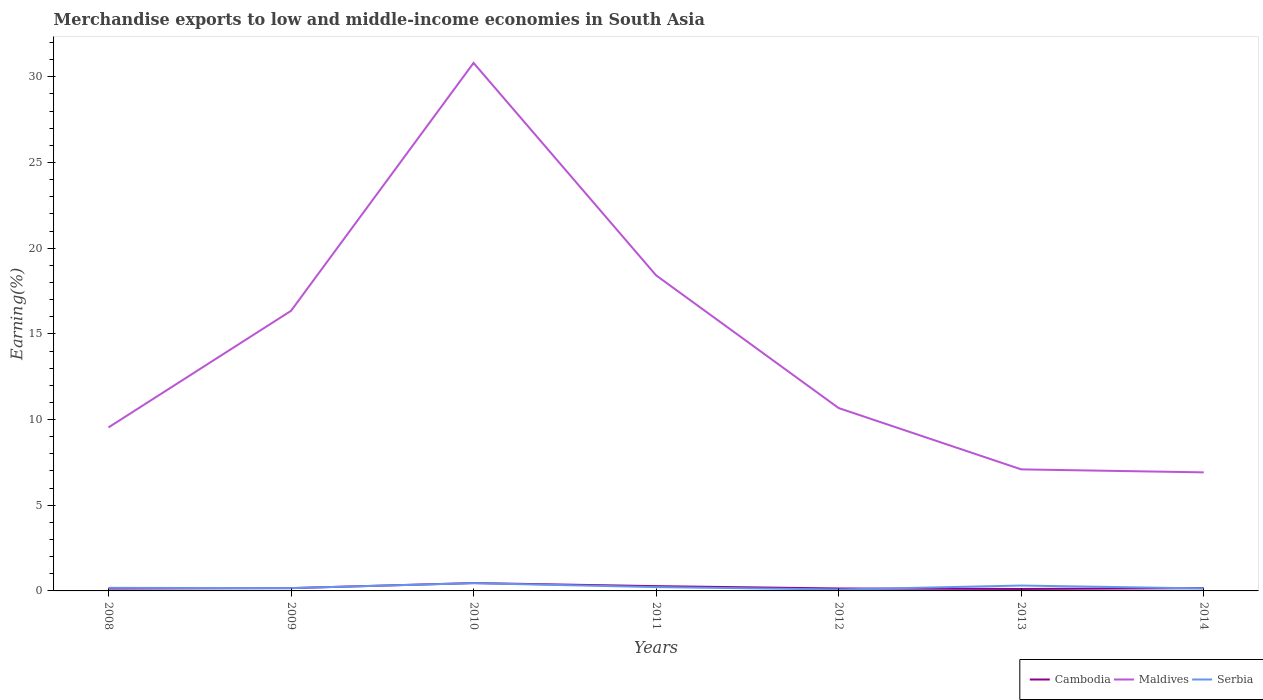Is the number of lines equal to the number of legend labels?
Make the answer very short. Yes. Across all years, what is the maximum percentage of amount earned from merchandise exports in Serbia?
Make the answer very short. 0.08. In which year was the percentage of amount earned from merchandise exports in Maldives maximum?
Provide a short and direct response. 2014. What is the total percentage of amount earned from merchandise exports in Maldives in the graph?
Offer a very short reply. 5.67. What is the difference between the highest and the second highest percentage of amount earned from merchandise exports in Cambodia?
Provide a short and direct response. 0.34. How many lines are there?
Your answer should be compact. 3. How many years are there in the graph?
Your answer should be compact. 7. Does the graph contain any zero values?
Provide a short and direct response. No. Where does the legend appear in the graph?
Ensure brevity in your answer.  Bottom right. What is the title of the graph?
Make the answer very short. Merchandise exports to low and middle-income economies in South Asia. What is the label or title of the X-axis?
Your answer should be compact. Years. What is the label or title of the Y-axis?
Your answer should be compact. Earning(%). What is the Earning(%) in Cambodia in 2008?
Offer a very short reply. 0.14. What is the Earning(%) of Maldives in 2008?
Keep it short and to the point. 9.54. What is the Earning(%) of Serbia in 2008?
Offer a terse response. 0.18. What is the Earning(%) in Cambodia in 2009?
Keep it short and to the point. 0.16. What is the Earning(%) in Maldives in 2009?
Offer a terse response. 16.35. What is the Earning(%) in Serbia in 2009?
Keep it short and to the point. 0.16. What is the Earning(%) of Cambodia in 2010?
Your answer should be very brief. 0.46. What is the Earning(%) in Maldives in 2010?
Provide a succinct answer. 30.81. What is the Earning(%) in Serbia in 2010?
Your answer should be compact. 0.45. What is the Earning(%) in Cambodia in 2011?
Make the answer very short. 0.28. What is the Earning(%) of Maldives in 2011?
Keep it short and to the point. 18.41. What is the Earning(%) in Serbia in 2011?
Provide a short and direct response. 0.22. What is the Earning(%) in Cambodia in 2012?
Provide a short and direct response. 0.14. What is the Earning(%) of Maldives in 2012?
Keep it short and to the point. 10.67. What is the Earning(%) in Serbia in 2012?
Your answer should be compact. 0.08. What is the Earning(%) in Cambodia in 2013?
Your answer should be compact. 0.11. What is the Earning(%) in Maldives in 2013?
Provide a short and direct response. 7.09. What is the Earning(%) in Serbia in 2013?
Provide a succinct answer. 0.31. What is the Earning(%) in Cambodia in 2014?
Your answer should be very brief. 0.16. What is the Earning(%) in Maldives in 2014?
Your response must be concise. 6.92. What is the Earning(%) in Serbia in 2014?
Your response must be concise. 0.14. Across all years, what is the maximum Earning(%) of Cambodia?
Provide a succinct answer. 0.46. Across all years, what is the maximum Earning(%) in Maldives?
Offer a very short reply. 30.81. Across all years, what is the maximum Earning(%) of Serbia?
Offer a terse response. 0.45. Across all years, what is the minimum Earning(%) in Cambodia?
Keep it short and to the point. 0.11. Across all years, what is the minimum Earning(%) in Maldives?
Your answer should be very brief. 6.92. Across all years, what is the minimum Earning(%) of Serbia?
Give a very brief answer. 0.08. What is the total Earning(%) of Cambodia in the graph?
Give a very brief answer. 1.45. What is the total Earning(%) of Maldives in the graph?
Your response must be concise. 99.79. What is the total Earning(%) of Serbia in the graph?
Your response must be concise. 1.56. What is the difference between the Earning(%) of Cambodia in 2008 and that in 2009?
Offer a terse response. -0.03. What is the difference between the Earning(%) in Maldives in 2008 and that in 2009?
Ensure brevity in your answer.  -6.81. What is the difference between the Earning(%) in Serbia in 2008 and that in 2009?
Make the answer very short. 0.02. What is the difference between the Earning(%) in Cambodia in 2008 and that in 2010?
Your answer should be compact. -0.32. What is the difference between the Earning(%) of Maldives in 2008 and that in 2010?
Your response must be concise. -21.27. What is the difference between the Earning(%) of Serbia in 2008 and that in 2010?
Provide a succinct answer. -0.27. What is the difference between the Earning(%) in Cambodia in 2008 and that in 2011?
Provide a succinct answer. -0.14. What is the difference between the Earning(%) in Maldives in 2008 and that in 2011?
Your answer should be very brief. -8.87. What is the difference between the Earning(%) of Serbia in 2008 and that in 2011?
Your response must be concise. -0.04. What is the difference between the Earning(%) in Cambodia in 2008 and that in 2012?
Provide a short and direct response. -0.01. What is the difference between the Earning(%) in Maldives in 2008 and that in 2012?
Provide a short and direct response. -1.13. What is the difference between the Earning(%) in Serbia in 2008 and that in 2012?
Give a very brief answer. 0.1. What is the difference between the Earning(%) in Cambodia in 2008 and that in 2013?
Provide a succinct answer. 0.02. What is the difference between the Earning(%) of Maldives in 2008 and that in 2013?
Your response must be concise. 2.45. What is the difference between the Earning(%) of Serbia in 2008 and that in 2013?
Give a very brief answer. -0.13. What is the difference between the Earning(%) of Cambodia in 2008 and that in 2014?
Provide a short and direct response. -0.03. What is the difference between the Earning(%) of Maldives in 2008 and that in 2014?
Provide a succinct answer. 2.62. What is the difference between the Earning(%) in Serbia in 2008 and that in 2014?
Give a very brief answer. 0.04. What is the difference between the Earning(%) of Cambodia in 2009 and that in 2010?
Your answer should be compact. -0.3. What is the difference between the Earning(%) in Maldives in 2009 and that in 2010?
Keep it short and to the point. -14.47. What is the difference between the Earning(%) of Serbia in 2009 and that in 2010?
Provide a succinct answer. -0.29. What is the difference between the Earning(%) of Cambodia in 2009 and that in 2011?
Ensure brevity in your answer.  -0.11. What is the difference between the Earning(%) in Maldives in 2009 and that in 2011?
Keep it short and to the point. -2.07. What is the difference between the Earning(%) in Serbia in 2009 and that in 2011?
Ensure brevity in your answer.  -0.06. What is the difference between the Earning(%) of Cambodia in 2009 and that in 2012?
Keep it short and to the point. 0.02. What is the difference between the Earning(%) in Maldives in 2009 and that in 2012?
Offer a very short reply. 5.67. What is the difference between the Earning(%) in Serbia in 2009 and that in 2012?
Provide a short and direct response. 0.08. What is the difference between the Earning(%) of Cambodia in 2009 and that in 2013?
Provide a short and direct response. 0.05. What is the difference between the Earning(%) of Maldives in 2009 and that in 2013?
Your answer should be compact. 9.25. What is the difference between the Earning(%) of Serbia in 2009 and that in 2013?
Your answer should be compact. -0.15. What is the difference between the Earning(%) of Cambodia in 2009 and that in 2014?
Ensure brevity in your answer.  0. What is the difference between the Earning(%) in Maldives in 2009 and that in 2014?
Offer a terse response. 9.43. What is the difference between the Earning(%) of Serbia in 2009 and that in 2014?
Offer a terse response. 0.02. What is the difference between the Earning(%) of Cambodia in 2010 and that in 2011?
Provide a succinct answer. 0.18. What is the difference between the Earning(%) in Maldives in 2010 and that in 2011?
Offer a very short reply. 12.4. What is the difference between the Earning(%) of Serbia in 2010 and that in 2011?
Make the answer very short. 0.23. What is the difference between the Earning(%) in Cambodia in 2010 and that in 2012?
Offer a terse response. 0.32. What is the difference between the Earning(%) of Maldives in 2010 and that in 2012?
Provide a succinct answer. 20.14. What is the difference between the Earning(%) in Serbia in 2010 and that in 2012?
Your response must be concise. 0.37. What is the difference between the Earning(%) of Cambodia in 2010 and that in 2013?
Keep it short and to the point. 0.34. What is the difference between the Earning(%) in Maldives in 2010 and that in 2013?
Provide a short and direct response. 23.72. What is the difference between the Earning(%) of Serbia in 2010 and that in 2013?
Give a very brief answer. 0.14. What is the difference between the Earning(%) of Cambodia in 2010 and that in 2014?
Give a very brief answer. 0.3. What is the difference between the Earning(%) in Maldives in 2010 and that in 2014?
Make the answer very short. 23.89. What is the difference between the Earning(%) in Serbia in 2010 and that in 2014?
Your answer should be very brief. 0.31. What is the difference between the Earning(%) of Cambodia in 2011 and that in 2012?
Offer a very short reply. 0.14. What is the difference between the Earning(%) of Maldives in 2011 and that in 2012?
Provide a short and direct response. 7.74. What is the difference between the Earning(%) of Serbia in 2011 and that in 2012?
Give a very brief answer. 0.14. What is the difference between the Earning(%) of Cambodia in 2011 and that in 2013?
Offer a terse response. 0.16. What is the difference between the Earning(%) of Maldives in 2011 and that in 2013?
Ensure brevity in your answer.  11.32. What is the difference between the Earning(%) of Serbia in 2011 and that in 2013?
Keep it short and to the point. -0.09. What is the difference between the Earning(%) of Cambodia in 2011 and that in 2014?
Ensure brevity in your answer.  0.12. What is the difference between the Earning(%) of Maldives in 2011 and that in 2014?
Offer a very short reply. 11.5. What is the difference between the Earning(%) in Serbia in 2011 and that in 2014?
Your answer should be very brief. 0.08. What is the difference between the Earning(%) of Cambodia in 2012 and that in 2013?
Provide a succinct answer. 0.03. What is the difference between the Earning(%) in Maldives in 2012 and that in 2013?
Offer a terse response. 3.58. What is the difference between the Earning(%) of Serbia in 2012 and that in 2013?
Your answer should be very brief. -0.23. What is the difference between the Earning(%) of Cambodia in 2012 and that in 2014?
Your answer should be very brief. -0.02. What is the difference between the Earning(%) in Maldives in 2012 and that in 2014?
Keep it short and to the point. 3.75. What is the difference between the Earning(%) of Serbia in 2012 and that in 2014?
Your answer should be compact. -0.06. What is the difference between the Earning(%) in Cambodia in 2013 and that in 2014?
Keep it short and to the point. -0.05. What is the difference between the Earning(%) of Maldives in 2013 and that in 2014?
Provide a succinct answer. 0.17. What is the difference between the Earning(%) in Serbia in 2013 and that in 2014?
Your answer should be compact. 0.17. What is the difference between the Earning(%) of Cambodia in 2008 and the Earning(%) of Maldives in 2009?
Provide a short and direct response. -16.21. What is the difference between the Earning(%) in Cambodia in 2008 and the Earning(%) in Serbia in 2009?
Keep it short and to the point. -0.03. What is the difference between the Earning(%) in Maldives in 2008 and the Earning(%) in Serbia in 2009?
Offer a terse response. 9.38. What is the difference between the Earning(%) of Cambodia in 2008 and the Earning(%) of Maldives in 2010?
Your response must be concise. -30.68. What is the difference between the Earning(%) in Cambodia in 2008 and the Earning(%) in Serbia in 2010?
Provide a short and direct response. -0.32. What is the difference between the Earning(%) in Maldives in 2008 and the Earning(%) in Serbia in 2010?
Offer a very short reply. 9.09. What is the difference between the Earning(%) of Cambodia in 2008 and the Earning(%) of Maldives in 2011?
Your answer should be compact. -18.28. What is the difference between the Earning(%) in Cambodia in 2008 and the Earning(%) in Serbia in 2011?
Offer a terse response. -0.09. What is the difference between the Earning(%) in Maldives in 2008 and the Earning(%) in Serbia in 2011?
Offer a very short reply. 9.32. What is the difference between the Earning(%) of Cambodia in 2008 and the Earning(%) of Maldives in 2012?
Provide a short and direct response. -10.54. What is the difference between the Earning(%) in Cambodia in 2008 and the Earning(%) in Serbia in 2012?
Make the answer very short. 0.05. What is the difference between the Earning(%) of Maldives in 2008 and the Earning(%) of Serbia in 2012?
Keep it short and to the point. 9.46. What is the difference between the Earning(%) of Cambodia in 2008 and the Earning(%) of Maldives in 2013?
Keep it short and to the point. -6.96. What is the difference between the Earning(%) of Cambodia in 2008 and the Earning(%) of Serbia in 2013?
Offer a very short reply. -0.18. What is the difference between the Earning(%) of Maldives in 2008 and the Earning(%) of Serbia in 2013?
Give a very brief answer. 9.23. What is the difference between the Earning(%) in Cambodia in 2008 and the Earning(%) in Maldives in 2014?
Offer a terse response. -6.78. What is the difference between the Earning(%) of Cambodia in 2008 and the Earning(%) of Serbia in 2014?
Give a very brief answer. -0.01. What is the difference between the Earning(%) of Maldives in 2008 and the Earning(%) of Serbia in 2014?
Provide a succinct answer. 9.4. What is the difference between the Earning(%) of Cambodia in 2009 and the Earning(%) of Maldives in 2010?
Give a very brief answer. -30.65. What is the difference between the Earning(%) of Cambodia in 2009 and the Earning(%) of Serbia in 2010?
Make the answer very short. -0.29. What is the difference between the Earning(%) in Maldives in 2009 and the Earning(%) in Serbia in 2010?
Ensure brevity in your answer.  15.89. What is the difference between the Earning(%) of Cambodia in 2009 and the Earning(%) of Maldives in 2011?
Provide a succinct answer. -18.25. What is the difference between the Earning(%) of Cambodia in 2009 and the Earning(%) of Serbia in 2011?
Provide a succinct answer. -0.06. What is the difference between the Earning(%) of Maldives in 2009 and the Earning(%) of Serbia in 2011?
Your answer should be compact. 16.12. What is the difference between the Earning(%) in Cambodia in 2009 and the Earning(%) in Maldives in 2012?
Provide a succinct answer. -10.51. What is the difference between the Earning(%) in Cambodia in 2009 and the Earning(%) in Serbia in 2012?
Ensure brevity in your answer.  0.08. What is the difference between the Earning(%) in Maldives in 2009 and the Earning(%) in Serbia in 2012?
Your response must be concise. 16.26. What is the difference between the Earning(%) in Cambodia in 2009 and the Earning(%) in Maldives in 2013?
Keep it short and to the point. -6.93. What is the difference between the Earning(%) of Cambodia in 2009 and the Earning(%) of Serbia in 2013?
Your answer should be compact. -0.15. What is the difference between the Earning(%) in Maldives in 2009 and the Earning(%) in Serbia in 2013?
Ensure brevity in your answer.  16.03. What is the difference between the Earning(%) in Cambodia in 2009 and the Earning(%) in Maldives in 2014?
Make the answer very short. -6.76. What is the difference between the Earning(%) in Cambodia in 2009 and the Earning(%) in Serbia in 2014?
Your response must be concise. 0.02. What is the difference between the Earning(%) of Maldives in 2009 and the Earning(%) of Serbia in 2014?
Your answer should be very brief. 16.2. What is the difference between the Earning(%) of Cambodia in 2010 and the Earning(%) of Maldives in 2011?
Provide a short and direct response. -17.96. What is the difference between the Earning(%) of Cambodia in 2010 and the Earning(%) of Serbia in 2011?
Provide a short and direct response. 0.24. What is the difference between the Earning(%) in Maldives in 2010 and the Earning(%) in Serbia in 2011?
Keep it short and to the point. 30.59. What is the difference between the Earning(%) in Cambodia in 2010 and the Earning(%) in Maldives in 2012?
Make the answer very short. -10.21. What is the difference between the Earning(%) of Cambodia in 2010 and the Earning(%) of Serbia in 2012?
Your response must be concise. 0.38. What is the difference between the Earning(%) of Maldives in 2010 and the Earning(%) of Serbia in 2012?
Make the answer very short. 30.73. What is the difference between the Earning(%) in Cambodia in 2010 and the Earning(%) in Maldives in 2013?
Provide a short and direct response. -6.63. What is the difference between the Earning(%) in Cambodia in 2010 and the Earning(%) in Serbia in 2013?
Ensure brevity in your answer.  0.14. What is the difference between the Earning(%) in Maldives in 2010 and the Earning(%) in Serbia in 2013?
Provide a short and direct response. 30.5. What is the difference between the Earning(%) in Cambodia in 2010 and the Earning(%) in Maldives in 2014?
Your response must be concise. -6.46. What is the difference between the Earning(%) of Cambodia in 2010 and the Earning(%) of Serbia in 2014?
Your answer should be very brief. 0.31. What is the difference between the Earning(%) in Maldives in 2010 and the Earning(%) in Serbia in 2014?
Give a very brief answer. 30.67. What is the difference between the Earning(%) in Cambodia in 2011 and the Earning(%) in Maldives in 2012?
Offer a terse response. -10.39. What is the difference between the Earning(%) in Cambodia in 2011 and the Earning(%) in Serbia in 2012?
Offer a terse response. 0.19. What is the difference between the Earning(%) in Maldives in 2011 and the Earning(%) in Serbia in 2012?
Offer a very short reply. 18.33. What is the difference between the Earning(%) in Cambodia in 2011 and the Earning(%) in Maldives in 2013?
Your answer should be very brief. -6.82. What is the difference between the Earning(%) in Cambodia in 2011 and the Earning(%) in Serbia in 2013?
Provide a succinct answer. -0.04. What is the difference between the Earning(%) of Maldives in 2011 and the Earning(%) of Serbia in 2013?
Provide a short and direct response. 18.1. What is the difference between the Earning(%) in Cambodia in 2011 and the Earning(%) in Maldives in 2014?
Provide a succinct answer. -6.64. What is the difference between the Earning(%) of Cambodia in 2011 and the Earning(%) of Serbia in 2014?
Offer a terse response. 0.13. What is the difference between the Earning(%) of Maldives in 2011 and the Earning(%) of Serbia in 2014?
Make the answer very short. 18.27. What is the difference between the Earning(%) in Cambodia in 2012 and the Earning(%) in Maldives in 2013?
Keep it short and to the point. -6.95. What is the difference between the Earning(%) of Cambodia in 2012 and the Earning(%) of Serbia in 2013?
Your answer should be compact. -0.17. What is the difference between the Earning(%) of Maldives in 2012 and the Earning(%) of Serbia in 2013?
Make the answer very short. 10.36. What is the difference between the Earning(%) of Cambodia in 2012 and the Earning(%) of Maldives in 2014?
Offer a terse response. -6.78. What is the difference between the Earning(%) in Cambodia in 2012 and the Earning(%) in Serbia in 2014?
Offer a terse response. -0. What is the difference between the Earning(%) of Maldives in 2012 and the Earning(%) of Serbia in 2014?
Provide a short and direct response. 10.53. What is the difference between the Earning(%) of Cambodia in 2013 and the Earning(%) of Maldives in 2014?
Make the answer very short. -6.8. What is the difference between the Earning(%) of Cambodia in 2013 and the Earning(%) of Serbia in 2014?
Give a very brief answer. -0.03. What is the difference between the Earning(%) in Maldives in 2013 and the Earning(%) in Serbia in 2014?
Keep it short and to the point. 6.95. What is the average Earning(%) of Cambodia per year?
Ensure brevity in your answer.  0.21. What is the average Earning(%) in Maldives per year?
Your answer should be compact. 14.26. What is the average Earning(%) in Serbia per year?
Your response must be concise. 0.22. In the year 2008, what is the difference between the Earning(%) of Cambodia and Earning(%) of Maldives?
Give a very brief answer. -9.4. In the year 2008, what is the difference between the Earning(%) of Cambodia and Earning(%) of Serbia?
Offer a terse response. -0.04. In the year 2008, what is the difference between the Earning(%) in Maldives and Earning(%) in Serbia?
Give a very brief answer. 9.36. In the year 2009, what is the difference between the Earning(%) of Cambodia and Earning(%) of Maldives?
Keep it short and to the point. -16.18. In the year 2009, what is the difference between the Earning(%) in Cambodia and Earning(%) in Serbia?
Offer a terse response. -0. In the year 2009, what is the difference between the Earning(%) of Maldives and Earning(%) of Serbia?
Keep it short and to the point. 16.18. In the year 2010, what is the difference between the Earning(%) in Cambodia and Earning(%) in Maldives?
Give a very brief answer. -30.35. In the year 2010, what is the difference between the Earning(%) in Cambodia and Earning(%) in Serbia?
Your answer should be very brief. 0.01. In the year 2010, what is the difference between the Earning(%) of Maldives and Earning(%) of Serbia?
Provide a short and direct response. 30.36. In the year 2011, what is the difference between the Earning(%) of Cambodia and Earning(%) of Maldives?
Ensure brevity in your answer.  -18.14. In the year 2011, what is the difference between the Earning(%) of Cambodia and Earning(%) of Serbia?
Offer a terse response. 0.06. In the year 2011, what is the difference between the Earning(%) of Maldives and Earning(%) of Serbia?
Your response must be concise. 18.19. In the year 2012, what is the difference between the Earning(%) of Cambodia and Earning(%) of Maldives?
Keep it short and to the point. -10.53. In the year 2012, what is the difference between the Earning(%) in Cambodia and Earning(%) in Serbia?
Provide a short and direct response. 0.06. In the year 2012, what is the difference between the Earning(%) in Maldives and Earning(%) in Serbia?
Ensure brevity in your answer.  10.59. In the year 2013, what is the difference between the Earning(%) of Cambodia and Earning(%) of Maldives?
Offer a terse response. -6.98. In the year 2013, what is the difference between the Earning(%) in Cambodia and Earning(%) in Serbia?
Your answer should be very brief. -0.2. In the year 2013, what is the difference between the Earning(%) in Maldives and Earning(%) in Serbia?
Give a very brief answer. 6.78. In the year 2014, what is the difference between the Earning(%) in Cambodia and Earning(%) in Maldives?
Provide a short and direct response. -6.76. In the year 2014, what is the difference between the Earning(%) in Cambodia and Earning(%) in Serbia?
Provide a short and direct response. 0.02. In the year 2014, what is the difference between the Earning(%) of Maldives and Earning(%) of Serbia?
Your answer should be very brief. 6.77. What is the ratio of the Earning(%) of Cambodia in 2008 to that in 2009?
Offer a terse response. 0.83. What is the ratio of the Earning(%) of Maldives in 2008 to that in 2009?
Provide a short and direct response. 0.58. What is the ratio of the Earning(%) of Serbia in 2008 to that in 2009?
Give a very brief answer. 1.1. What is the ratio of the Earning(%) of Cambodia in 2008 to that in 2010?
Give a very brief answer. 0.3. What is the ratio of the Earning(%) in Maldives in 2008 to that in 2010?
Give a very brief answer. 0.31. What is the ratio of the Earning(%) of Serbia in 2008 to that in 2010?
Give a very brief answer. 0.4. What is the ratio of the Earning(%) of Cambodia in 2008 to that in 2011?
Make the answer very short. 0.49. What is the ratio of the Earning(%) in Maldives in 2008 to that in 2011?
Offer a very short reply. 0.52. What is the ratio of the Earning(%) of Serbia in 2008 to that in 2011?
Provide a short and direct response. 0.81. What is the ratio of the Earning(%) of Cambodia in 2008 to that in 2012?
Provide a short and direct response. 0.95. What is the ratio of the Earning(%) in Maldives in 2008 to that in 2012?
Your answer should be compact. 0.89. What is the ratio of the Earning(%) in Serbia in 2008 to that in 2012?
Offer a terse response. 2.17. What is the ratio of the Earning(%) of Cambodia in 2008 to that in 2013?
Offer a very short reply. 1.19. What is the ratio of the Earning(%) in Maldives in 2008 to that in 2013?
Your response must be concise. 1.34. What is the ratio of the Earning(%) in Serbia in 2008 to that in 2013?
Your answer should be very brief. 0.57. What is the ratio of the Earning(%) in Cambodia in 2008 to that in 2014?
Offer a terse response. 0.84. What is the ratio of the Earning(%) in Maldives in 2008 to that in 2014?
Provide a succinct answer. 1.38. What is the ratio of the Earning(%) of Serbia in 2008 to that in 2014?
Your answer should be compact. 1.25. What is the ratio of the Earning(%) in Cambodia in 2009 to that in 2010?
Give a very brief answer. 0.36. What is the ratio of the Earning(%) in Maldives in 2009 to that in 2010?
Provide a short and direct response. 0.53. What is the ratio of the Earning(%) of Serbia in 2009 to that in 2010?
Your answer should be compact. 0.36. What is the ratio of the Earning(%) of Cambodia in 2009 to that in 2011?
Make the answer very short. 0.59. What is the ratio of the Earning(%) of Maldives in 2009 to that in 2011?
Give a very brief answer. 0.89. What is the ratio of the Earning(%) of Serbia in 2009 to that in 2011?
Your answer should be compact. 0.74. What is the ratio of the Earning(%) in Cambodia in 2009 to that in 2012?
Your response must be concise. 1.15. What is the ratio of the Earning(%) in Maldives in 2009 to that in 2012?
Your answer should be compact. 1.53. What is the ratio of the Earning(%) in Serbia in 2009 to that in 2012?
Offer a terse response. 1.98. What is the ratio of the Earning(%) in Cambodia in 2009 to that in 2013?
Give a very brief answer. 1.43. What is the ratio of the Earning(%) of Maldives in 2009 to that in 2013?
Provide a succinct answer. 2.3. What is the ratio of the Earning(%) of Serbia in 2009 to that in 2013?
Ensure brevity in your answer.  0.52. What is the ratio of the Earning(%) of Cambodia in 2009 to that in 2014?
Your response must be concise. 1.01. What is the ratio of the Earning(%) of Maldives in 2009 to that in 2014?
Ensure brevity in your answer.  2.36. What is the ratio of the Earning(%) of Serbia in 2009 to that in 2014?
Provide a short and direct response. 1.14. What is the ratio of the Earning(%) in Cambodia in 2010 to that in 2011?
Your response must be concise. 1.65. What is the ratio of the Earning(%) of Maldives in 2010 to that in 2011?
Ensure brevity in your answer.  1.67. What is the ratio of the Earning(%) in Serbia in 2010 to that in 2011?
Provide a short and direct response. 2.03. What is the ratio of the Earning(%) of Cambodia in 2010 to that in 2012?
Make the answer very short. 3.22. What is the ratio of the Earning(%) in Maldives in 2010 to that in 2012?
Ensure brevity in your answer.  2.89. What is the ratio of the Earning(%) in Serbia in 2010 to that in 2012?
Your answer should be compact. 5.47. What is the ratio of the Earning(%) in Cambodia in 2010 to that in 2013?
Your response must be concise. 4.01. What is the ratio of the Earning(%) in Maldives in 2010 to that in 2013?
Offer a very short reply. 4.34. What is the ratio of the Earning(%) of Serbia in 2010 to that in 2013?
Your response must be concise. 1.44. What is the ratio of the Earning(%) of Cambodia in 2010 to that in 2014?
Offer a very short reply. 2.83. What is the ratio of the Earning(%) in Maldives in 2010 to that in 2014?
Offer a very short reply. 4.45. What is the ratio of the Earning(%) in Serbia in 2010 to that in 2014?
Provide a short and direct response. 3.15. What is the ratio of the Earning(%) of Cambodia in 2011 to that in 2012?
Your answer should be compact. 1.95. What is the ratio of the Earning(%) in Maldives in 2011 to that in 2012?
Provide a short and direct response. 1.73. What is the ratio of the Earning(%) of Serbia in 2011 to that in 2012?
Your response must be concise. 2.69. What is the ratio of the Earning(%) of Cambodia in 2011 to that in 2013?
Provide a succinct answer. 2.43. What is the ratio of the Earning(%) in Maldives in 2011 to that in 2013?
Provide a succinct answer. 2.6. What is the ratio of the Earning(%) of Serbia in 2011 to that in 2013?
Offer a very short reply. 0.71. What is the ratio of the Earning(%) of Cambodia in 2011 to that in 2014?
Provide a succinct answer. 1.72. What is the ratio of the Earning(%) of Maldives in 2011 to that in 2014?
Keep it short and to the point. 2.66. What is the ratio of the Earning(%) in Serbia in 2011 to that in 2014?
Your answer should be very brief. 1.55. What is the ratio of the Earning(%) in Cambodia in 2012 to that in 2013?
Your answer should be compact. 1.24. What is the ratio of the Earning(%) in Maldives in 2012 to that in 2013?
Offer a very short reply. 1.5. What is the ratio of the Earning(%) in Serbia in 2012 to that in 2013?
Ensure brevity in your answer.  0.26. What is the ratio of the Earning(%) of Cambodia in 2012 to that in 2014?
Provide a short and direct response. 0.88. What is the ratio of the Earning(%) of Maldives in 2012 to that in 2014?
Provide a short and direct response. 1.54. What is the ratio of the Earning(%) of Serbia in 2012 to that in 2014?
Give a very brief answer. 0.58. What is the ratio of the Earning(%) in Cambodia in 2013 to that in 2014?
Your answer should be compact. 0.71. What is the ratio of the Earning(%) in Maldives in 2013 to that in 2014?
Keep it short and to the point. 1.03. What is the ratio of the Earning(%) in Serbia in 2013 to that in 2014?
Offer a terse response. 2.18. What is the difference between the highest and the second highest Earning(%) of Cambodia?
Offer a terse response. 0.18. What is the difference between the highest and the second highest Earning(%) in Maldives?
Your answer should be very brief. 12.4. What is the difference between the highest and the second highest Earning(%) in Serbia?
Make the answer very short. 0.14. What is the difference between the highest and the lowest Earning(%) in Cambodia?
Make the answer very short. 0.34. What is the difference between the highest and the lowest Earning(%) of Maldives?
Your answer should be compact. 23.89. What is the difference between the highest and the lowest Earning(%) of Serbia?
Offer a very short reply. 0.37. 